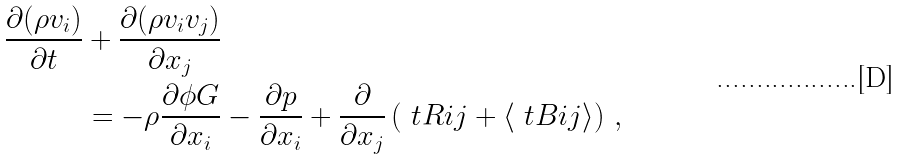<formula> <loc_0><loc_0><loc_500><loc_500>\frac { \partial ( \rho v _ { i } ) } { \partial t } & + \frac { \partial ( \rho v _ { i } v _ { j } ) } { \partial x _ { j } } \\ & = - \rho \frac { \partial \phi G } { \partial x _ { i } } - \frac { \partial p } { \partial x _ { i } } + \frac { \partial } { \partial x _ { j } } \left ( \ t R i j + \langle \ t B i j \rangle \right ) \, ,</formula> 